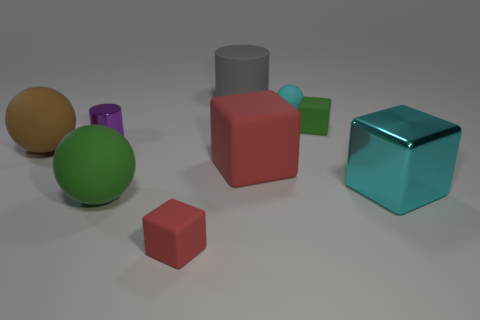Do the brown ball and the large cylinder have the same material?
Provide a succinct answer. Yes. There is a metallic thing to the left of the small rubber thing in front of the small cylinder; how many red rubber cubes are to the right of it?
Keep it short and to the point. 2. Is there a cylinder made of the same material as the large cyan block?
Ensure brevity in your answer.  Yes. The shiny object that is the same color as the tiny ball is what size?
Offer a terse response. Large. Are there fewer yellow matte blocks than small matte things?
Ensure brevity in your answer.  Yes. There is a ball that is right of the gray cylinder; is it the same color as the small metal object?
Ensure brevity in your answer.  No. What is the material of the big cylinder that is behind the purple cylinder that is in front of the green cube behind the small metal cylinder?
Give a very brief answer. Rubber. Are there any balls of the same color as the large matte block?
Your answer should be compact. No. Is the number of purple things that are behind the small rubber ball less than the number of big blue things?
Your response must be concise. No. There is a block in front of the cyan metallic block; is it the same size as the purple cylinder?
Keep it short and to the point. Yes. 